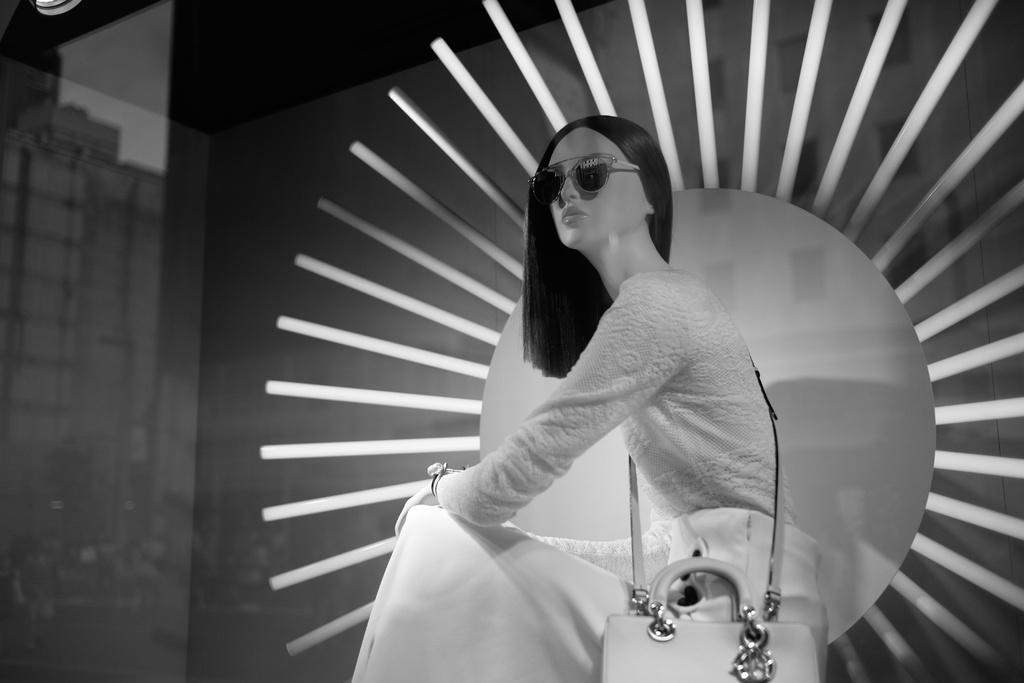What is the main subject in the center of the image? There is a mannequin in the center of the image. What accessories is the mannequin wearing? The mannequin is wearing glasses and a bag. What can be seen in the background of the image? There is a wall, a round shape object, and a few other objects in the background of the image. What type of branch can be seen growing from the mannequin's head in the image? There is no branch growing from the mannequin's head in the image. What is the direction of the zephyr in the image? There is no mention of a zephyr in the image, as it is a gentle wind that cannot be seen. 